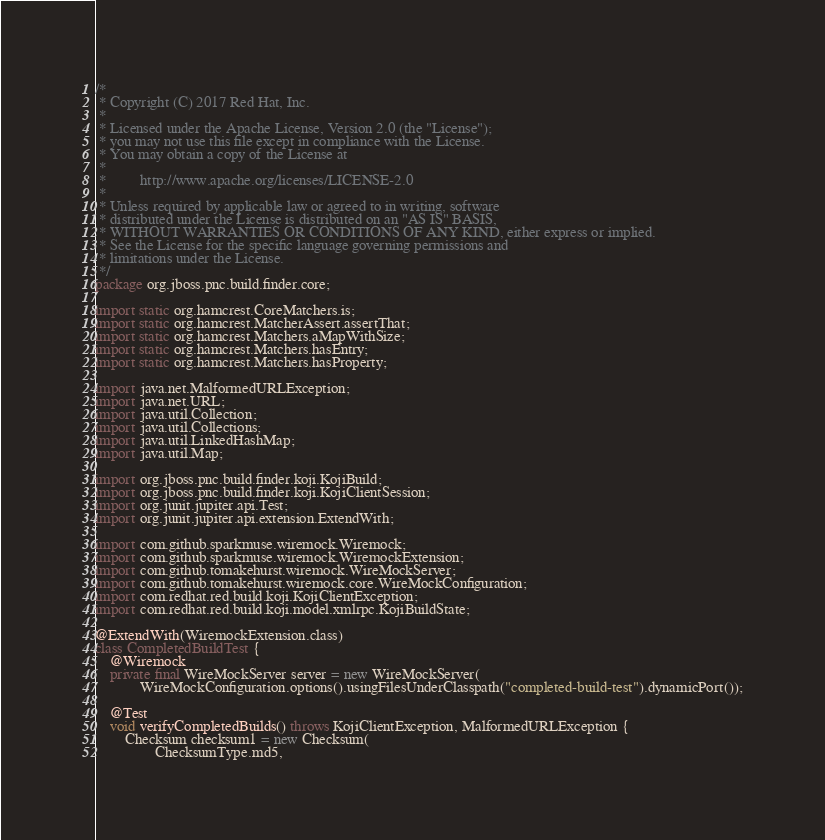<code> <loc_0><loc_0><loc_500><loc_500><_Java_>/*
 * Copyright (C) 2017 Red Hat, Inc.
 *
 * Licensed under the Apache License, Version 2.0 (the "License");
 * you may not use this file except in compliance with the License.
 * You may obtain a copy of the License at
 *
 *         http://www.apache.org/licenses/LICENSE-2.0
 *
 * Unless required by applicable law or agreed to in writing, software
 * distributed under the License is distributed on an "AS IS" BASIS,
 * WITHOUT WARRANTIES OR CONDITIONS OF ANY KIND, either express or implied.
 * See the License for the specific language governing permissions and
 * limitations under the License.
 */
package org.jboss.pnc.build.finder.core;

import static org.hamcrest.CoreMatchers.is;
import static org.hamcrest.MatcherAssert.assertThat;
import static org.hamcrest.Matchers.aMapWithSize;
import static org.hamcrest.Matchers.hasEntry;
import static org.hamcrest.Matchers.hasProperty;

import java.net.MalformedURLException;
import java.net.URL;
import java.util.Collection;
import java.util.Collections;
import java.util.LinkedHashMap;
import java.util.Map;

import org.jboss.pnc.build.finder.koji.KojiBuild;
import org.jboss.pnc.build.finder.koji.KojiClientSession;
import org.junit.jupiter.api.Test;
import org.junit.jupiter.api.extension.ExtendWith;

import com.github.sparkmuse.wiremock.Wiremock;
import com.github.sparkmuse.wiremock.WiremockExtension;
import com.github.tomakehurst.wiremock.WireMockServer;
import com.github.tomakehurst.wiremock.core.WireMockConfiguration;
import com.redhat.red.build.koji.KojiClientException;
import com.redhat.red.build.koji.model.xmlrpc.KojiBuildState;

@ExtendWith(WiremockExtension.class)
class CompletedBuildTest {
    @Wiremock
    private final WireMockServer server = new WireMockServer(
            WireMockConfiguration.options().usingFilesUnderClasspath("completed-build-test").dynamicPort());

    @Test
    void verifyCompletedBuilds() throws KojiClientException, MalformedURLException {
        Checksum checksum1 = new Checksum(
                ChecksumType.md5,</code> 